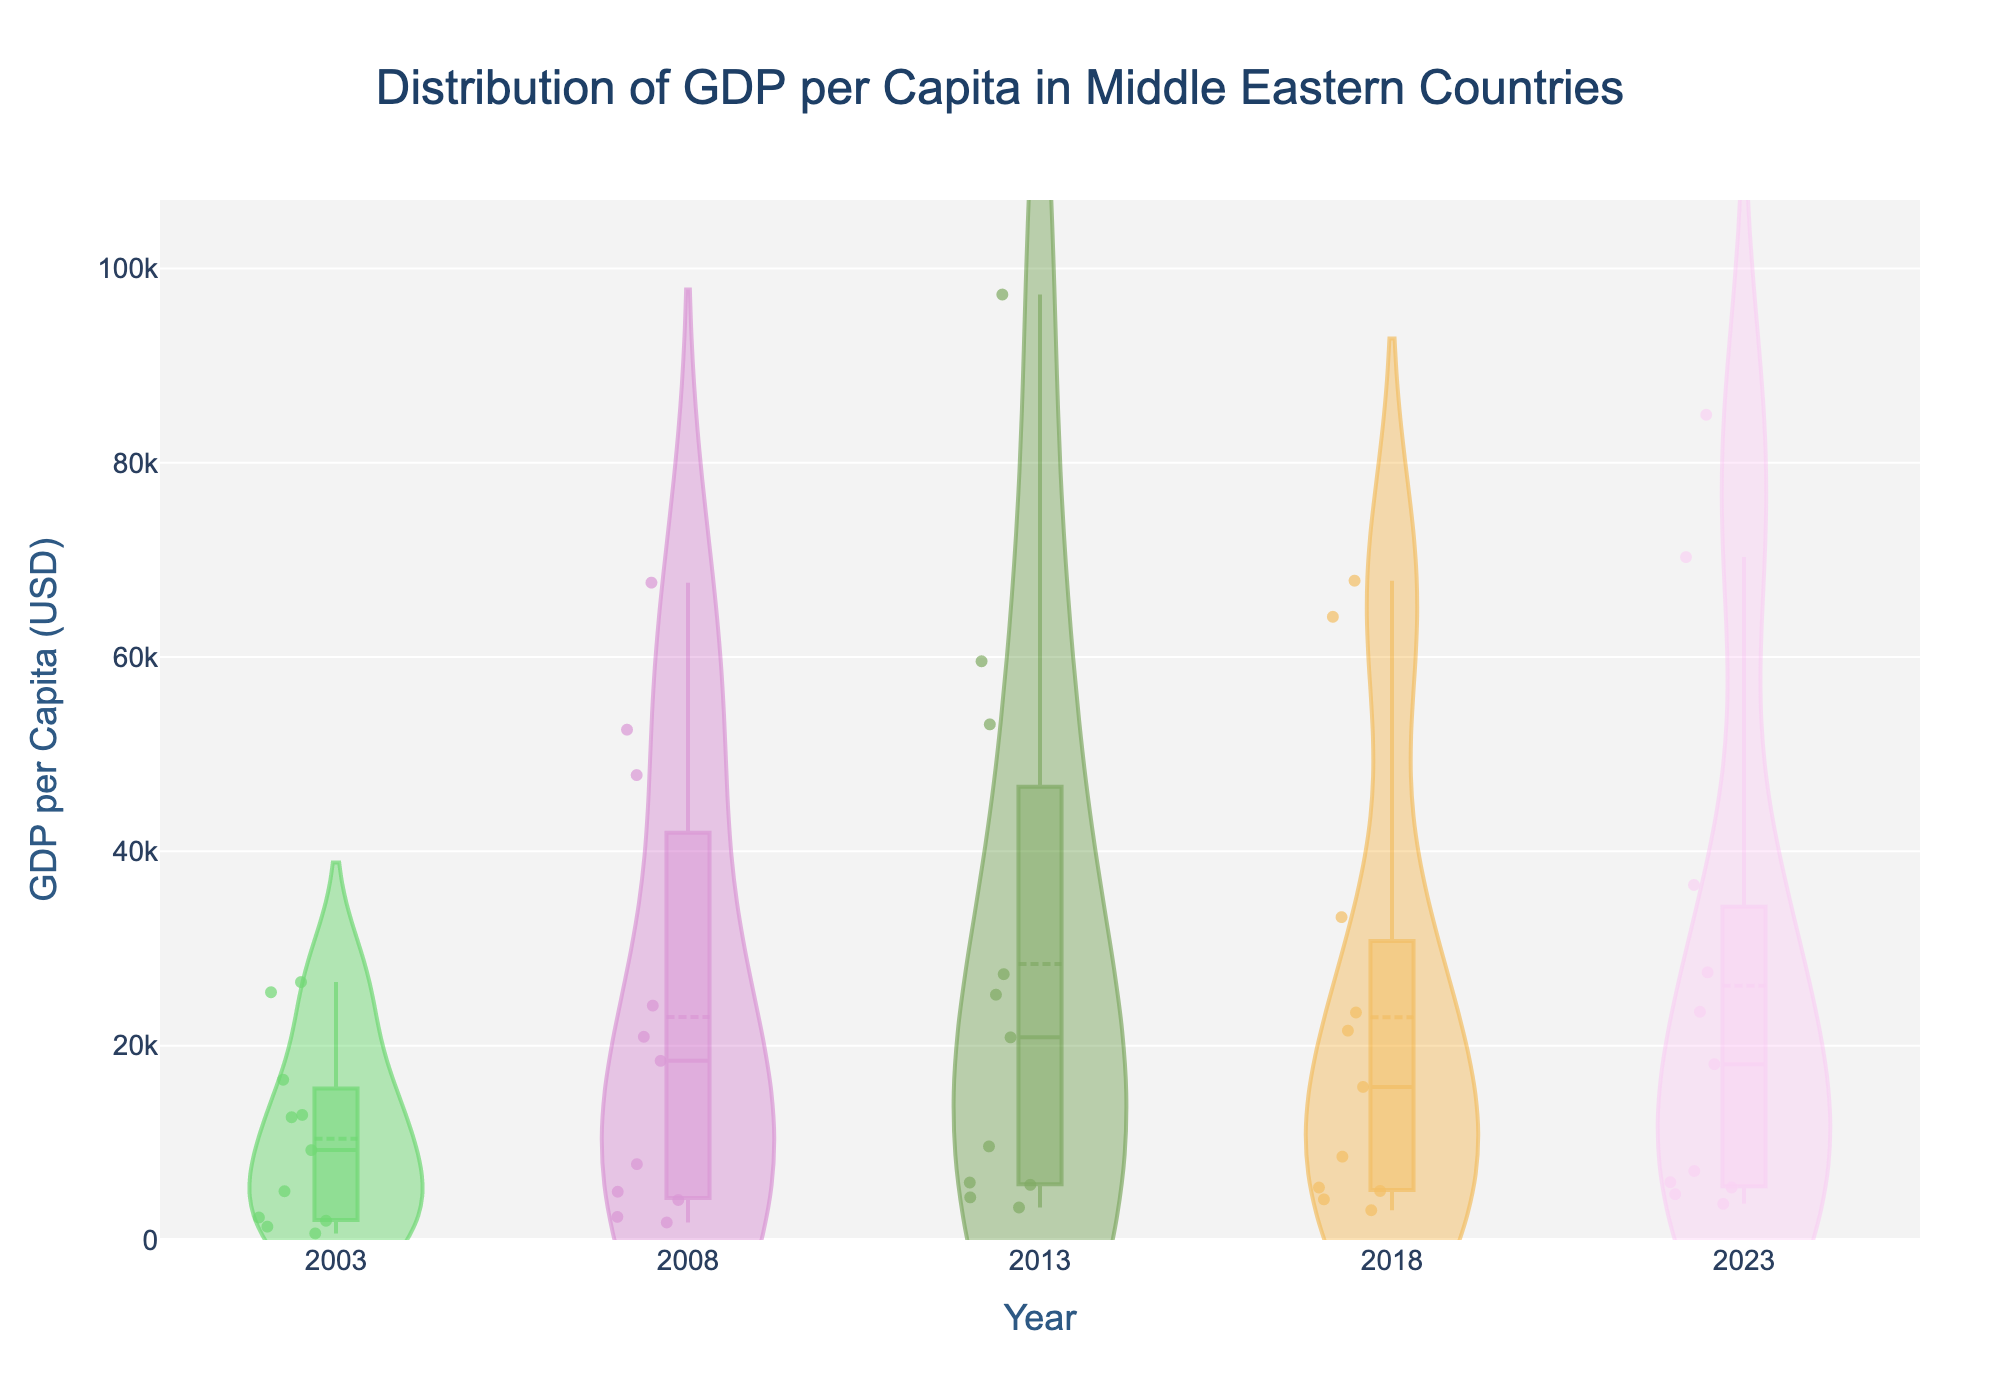What is the title of the figure? The title is usually positioned at the top of the figure. In this case, it reads "Distribution of GDP per Capita in Middle Eastern Countries".
Answer: Distribution of GDP per Capita in Middle Eastern Countries How many different years are represented in the figure? Observe the x-axis which indicates the years. The unique labels on the x-axis should show the count of years.
Answer: 5 What is the range of GDP per capita values displayed on the y-axis? Look at the y-axis ticks to determine the lowest and highest visible values.
Answer: 0 to approximately 97,307 USD Which year shows the highest mean GDP per capita? Each violin plot has a mean line. Comparing the positions of these lines across the years reveals which is highest.
Answer: 2013 In which year, the GDP per capita has the widest distribution? The width of each violin plot indicates the spread of GDP per capita for that year. The year with the widest violin plot illustrates the widest distribution.
Answer: 2023 What is the GDP per capita range for Oman in 2018? Find the 2018 violin plot and locate the highest and lowest points within the Oman data points.
Answer: Approximately 15,756 USD to 20,856 USD Which country had a significant increase in GDP per capita from 2003 to 2008? By observing the individual data points, identify the country with the largest gap between 2003 and 2008 values.
Answer: Qatar How does the distribution of GDP per capita in 2023 compare to 2003? Compare the width, shape, and spread of the violin plots for 2023 and 2003. The answer lies in the relative differences observed.
Answer: Much wider distribution in 2023 Which country consistently has one of the highest GDP per capita values across all years? Identify the country that appears in the upper range of the violin plots consistently for each year represented.
Answer: United Arab Emirates What year shows a narrow distribution of GDP per capita values across most countries? The narrowness of violin plots across different years can indicate this; the year with generally thinner plots will illustrate a narrow distribution.
Answer: 2003 